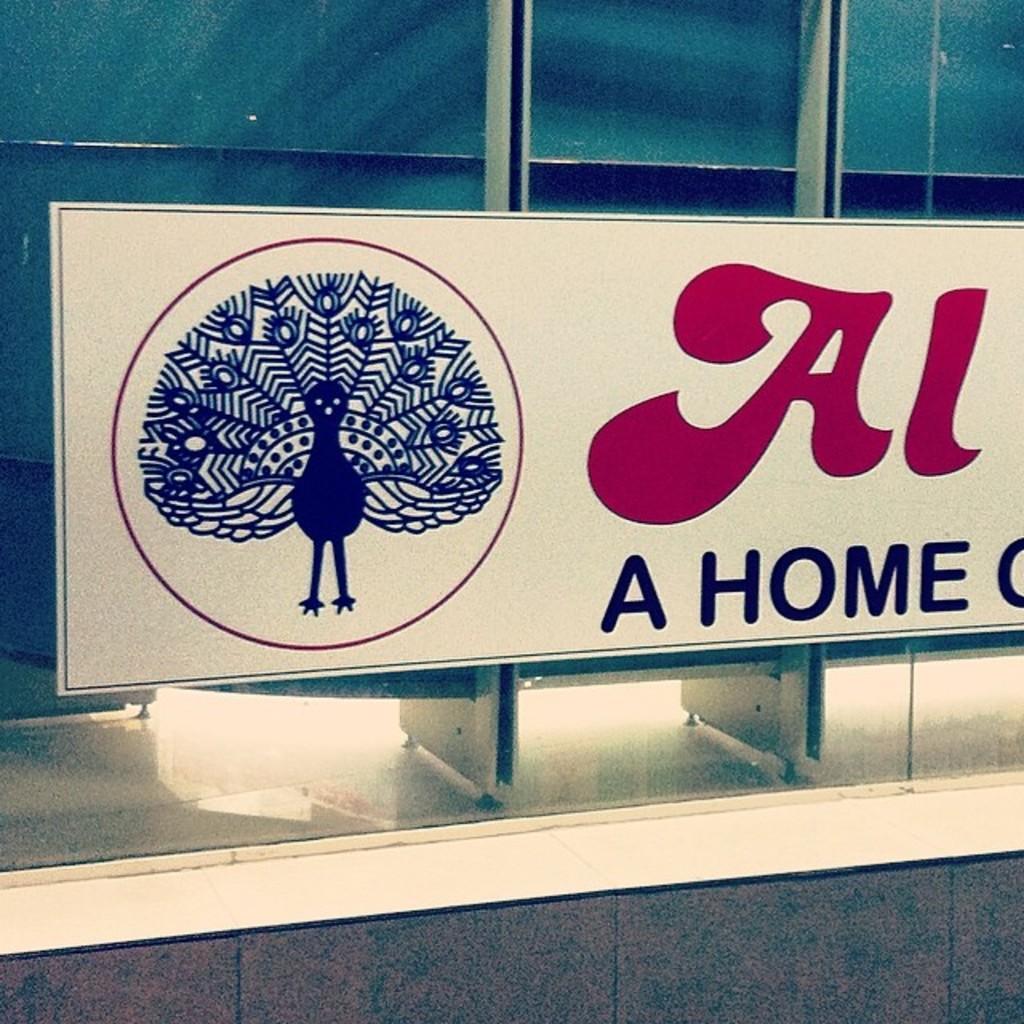Describe this image in one or two sentences. In the center of this picture we can see the board containing the text and the depiction of a peacock. In the background we can see the object which seems to be the window and we can see some other objects. 